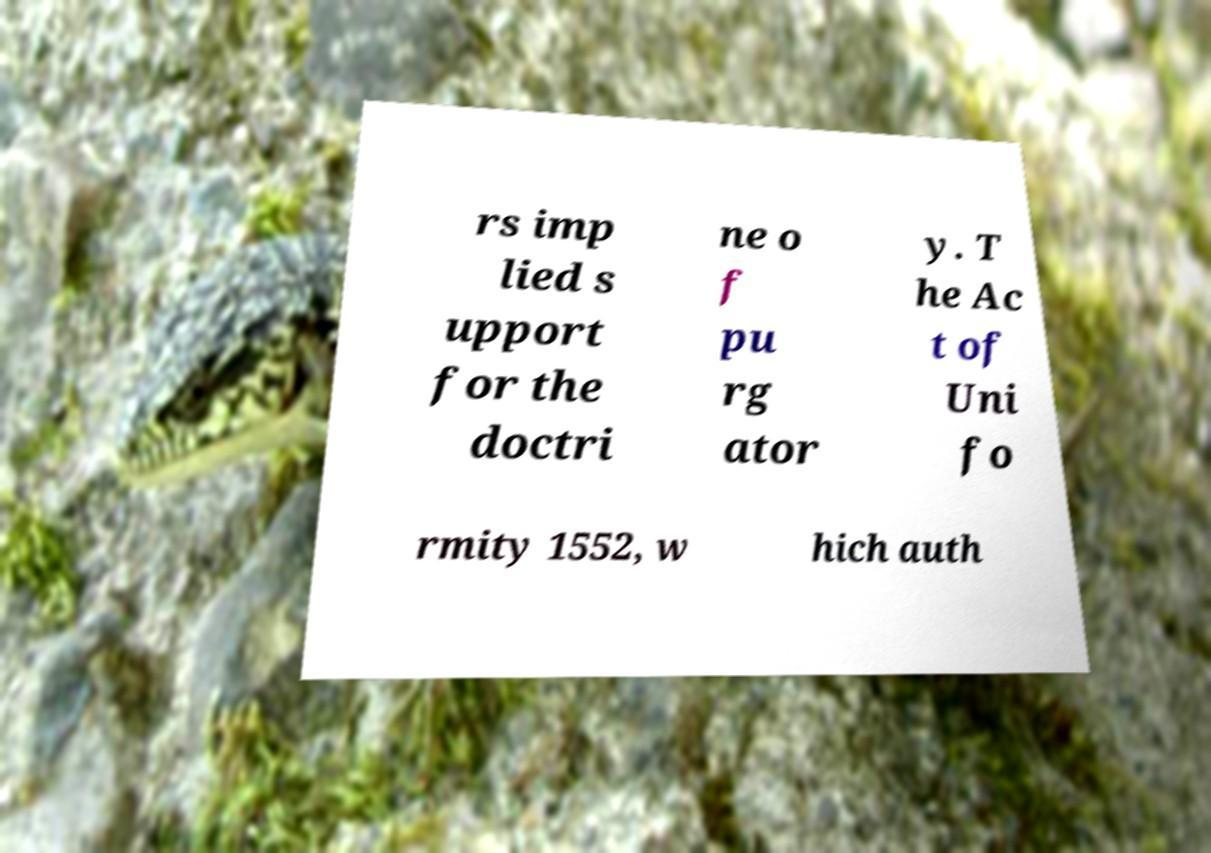There's text embedded in this image that I need extracted. Can you transcribe it verbatim? rs imp lied s upport for the doctri ne o f pu rg ator y. T he Ac t of Uni fo rmity 1552, w hich auth 